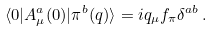<formula> <loc_0><loc_0><loc_500><loc_500>\langle 0 | A _ { \mu } ^ { a } ( 0 ) | \pi ^ { b } ( q ) \rangle = i q _ { \mu } f _ { \pi } \delta ^ { a b } \, .</formula> 